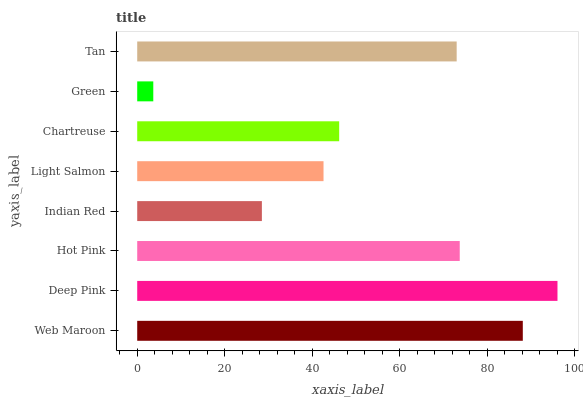Is Green the minimum?
Answer yes or no. Yes. Is Deep Pink the maximum?
Answer yes or no. Yes. Is Hot Pink the minimum?
Answer yes or no. No. Is Hot Pink the maximum?
Answer yes or no. No. Is Deep Pink greater than Hot Pink?
Answer yes or no. Yes. Is Hot Pink less than Deep Pink?
Answer yes or no. Yes. Is Hot Pink greater than Deep Pink?
Answer yes or no. No. Is Deep Pink less than Hot Pink?
Answer yes or no. No. Is Tan the high median?
Answer yes or no. Yes. Is Chartreuse the low median?
Answer yes or no. Yes. Is Deep Pink the high median?
Answer yes or no. No. Is Tan the low median?
Answer yes or no. No. 